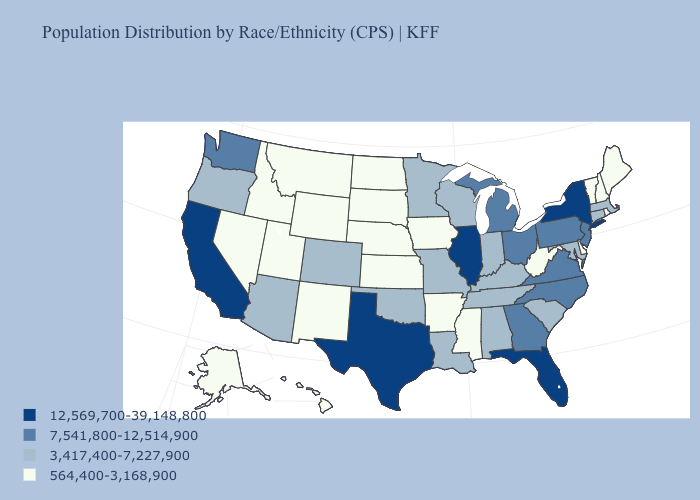Does South Dakota have the lowest value in the MidWest?
Concise answer only. Yes. What is the lowest value in the USA?
Concise answer only. 564,400-3,168,900. Name the states that have a value in the range 7,541,800-12,514,900?
Keep it brief. Georgia, Michigan, New Jersey, North Carolina, Ohio, Pennsylvania, Virginia, Washington. Which states have the lowest value in the USA?
Be succinct. Alaska, Arkansas, Delaware, Hawaii, Idaho, Iowa, Kansas, Maine, Mississippi, Montana, Nebraska, Nevada, New Hampshire, New Mexico, North Dakota, Rhode Island, South Dakota, Utah, Vermont, West Virginia, Wyoming. Among the states that border Iowa , which have the highest value?
Concise answer only. Illinois. Among the states that border Illinois , does Indiana have the highest value?
Short answer required. Yes. What is the lowest value in states that border New Mexico?
Give a very brief answer. 564,400-3,168,900. Name the states that have a value in the range 7,541,800-12,514,900?
Short answer required. Georgia, Michigan, New Jersey, North Carolina, Ohio, Pennsylvania, Virginia, Washington. What is the lowest value in the Northeast?
Concise answer only. 564,400-3,168,900. What is the value of Rhode Island?
Write a very short answer. 564,400-3,168,900. What is the highest value in the USA?
Short answer required. 12,569,700-39,148,800. Is the legend a continuous bar?
Answer briefly. No. What is the value of Rhode Island?
Write a very short answer. 564,400-3,168,900. Does Connecticut have the same value as Kentucky?
Keep it brief. Yes. What is the value of West Virginia?
Be succinct. 564,400-3,168,900. 